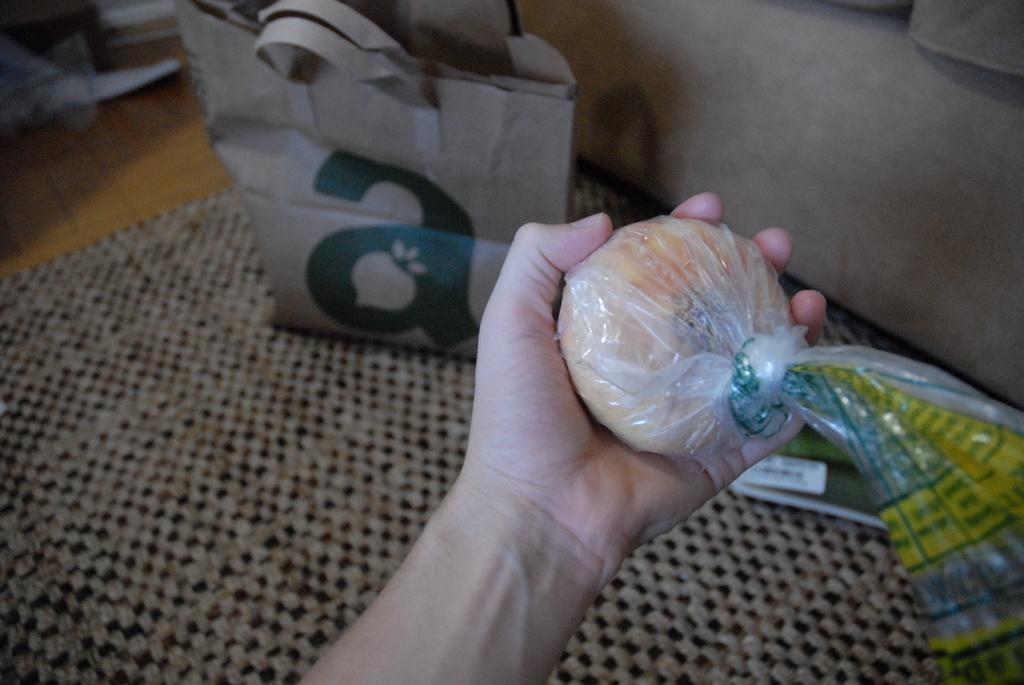What is the person's hand holding in the image? The person's hand is holding a bread and plastic cover in the image. What else can be seen on the table in the image? There is a paper cover and a book on the table. What type of material is the cloth near the wall on the table made of? The cloth near the wall on the table is made of fabric. Can you see a snake slithering across the table in the image? No, there is no snake present in the image. What type of payment is being made on the table in the image? There is no payment being made in the image; it only shows a person's hand holding a bread and plastic cover, a paper cover, a book, and a cloth near the wall on the table. 